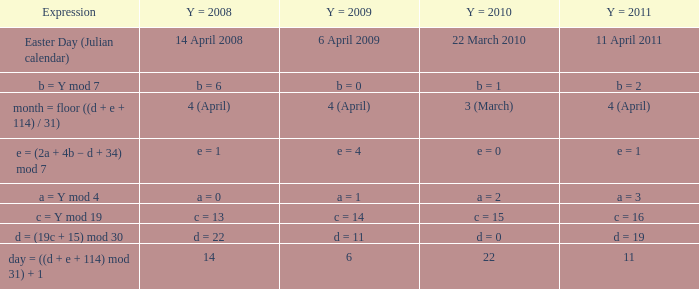What is the y = 2008 when y = 2011 is a = 3? A = 0. 